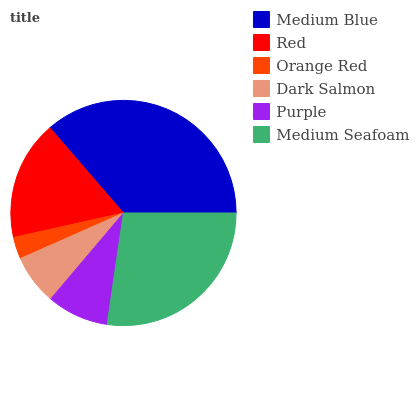Is Orange Red the minimum?
Answer yes or no. Yes. Is Medium Blue the maximum?
Answer yes or no. Yes. Is Red the minimum?
Answer yes or no. No. Is Red the maximum?
Answer yes or no. No. Is Medium Blue greater than Red?
Answer yes or no. Yes. Is Red less than Medium Blue?
Answer yes or no. Yes. Is Red greater than Medium Blue?
Answer yes or no. No. Is Medium Blue less than Red?
Answer yes or no. No. Is Red the high median?
Answer yes or no. Yes. Is Purple the low median?
Answer yes or no. Yes. Is Medium Blue the high median?
Answer yes or no. No. Is Medium Seafoam the low median?
Answer yes or no. No. 